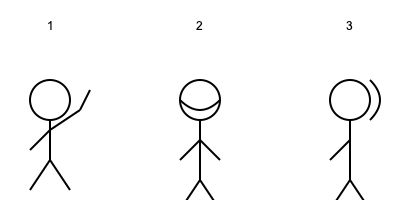Which of the illustrated gestures (1, 2, or 3) is commonly used in many Western cultures to indicate agreement or approval? Let's analyze each gesture in the image:

1. Figure 1 shows a stick figure with one arm raised and the thumb pointing upwards. This gesture is known as a "thumbs up" and is widely recognized in many Western cultures as a sign of approval, agreement, or that everything is good.

2. Figure 2 depicts a stick figure with its head tilted forward and an arrow indicating a downward motion. This represents nodding, which is often used to indicate agreement or understanding in many cultures.

3. Figure 3 shows a stick figure with one arm raised and moving side to side. This represents waving, which is typically used as a greeting or farewell gesture.

Among these three gestures, the one that most directly indicates agreement or approval in Western cultures is the "thumbs up" gesture shown in Figure 1. While nodding (Figure 2) can also indicate agreement, the question specifically asks for the gesture commonly used to show approval, making the thumbs up the most appropriate answer.
Answer: 1 